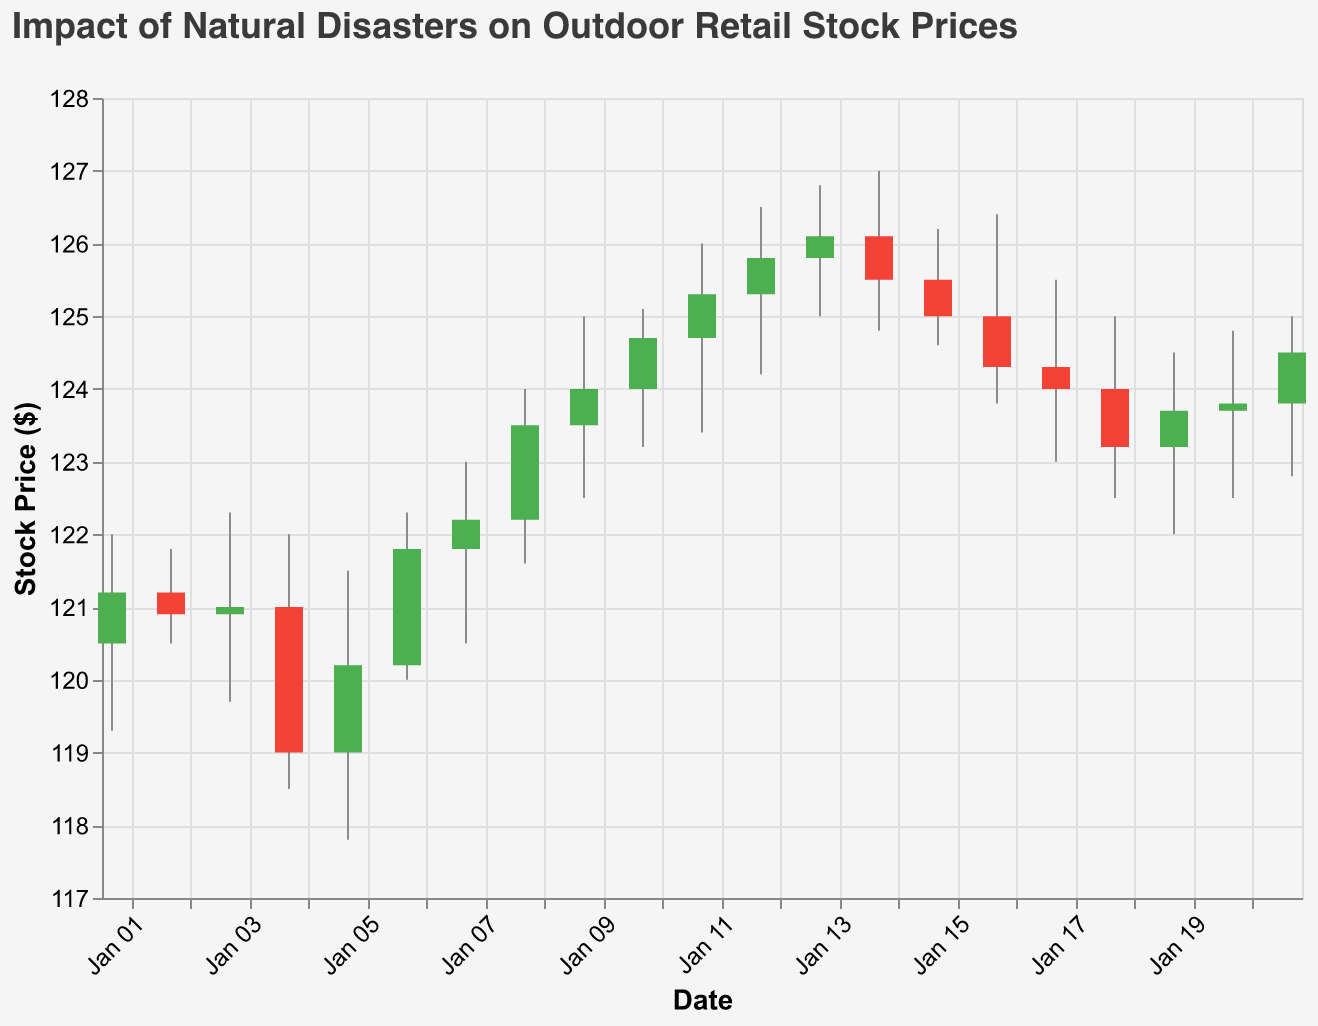What is the title of the chart? The title is usually displayed at the top of the chart and is meant to give an overview of what the data represents. In this chart, the title is "Impact of Natural Disasters on Outdoor Retail Stock Prices".
Answer: Impact of Natural Disasters on Outdoor Retail Stock Prices On which day did the stock price decrease the most? To find the day with the biggest decrease, look for the largest difference where the close price is significantly lower than the open price. Comparing the values, January 4th shows a significant drop from Open (121.00) to Close (119.00).
Answer: January 4th How did the stock price react immediately after the earthquake on January 6th? To see the reaction, examine the days following January 6th. On January 7th, the stock opened at 121.80 and closed higher at 122.20, indicating a slight increase.
Answer: It increased What was the highest stock price recorded in the data set? To find the peak stock price, look at the High column to find the maximum value. The highest price recorded is 127.00 on January 14th.
Answer: 127.00 What were the closing prices during the flood event on January 16th and 17th? Check the Close prices for these specific dates. On January 16th, the Close was 124.30, and on January 17th, it was 124.00.
Answer: 124.30 and 124.00 Calculate the average closing price from January 1st to January 21st. Sum all the closing prices and divide by the number of days. Adding all Close values (121.20 + 120.90 + 121.00 + 119.00 + 120.20 + 121.80 + 122.20 + 123.50 + 124.00 + 124.70 + 125.30 + 125.80 + 126.10 + 125.50 + 125.00 + 124.30 + 124.00 + 123.20 + 123.70 + 123.80 + 124.50) gives a total of 2562.20. Dividing by 21 days, the average is approximately 122.01.
Answer: 122.01 Did the volume increase or decrease after the flood on January 16th? Examine the Volume values before and after January 16th. On January 16th, the volume was 1400000, and on January 17th, it was 1370000. The volume decreased.
Answer: It decreased How did the closing price change between January 11th and January 13th? Look at the Close prices for these two dates. On January 11th, the Close was 125.30, and on January 13th, it was 126.10. Thus, it increased by 0.80.
Answer: It increased by 0.80 